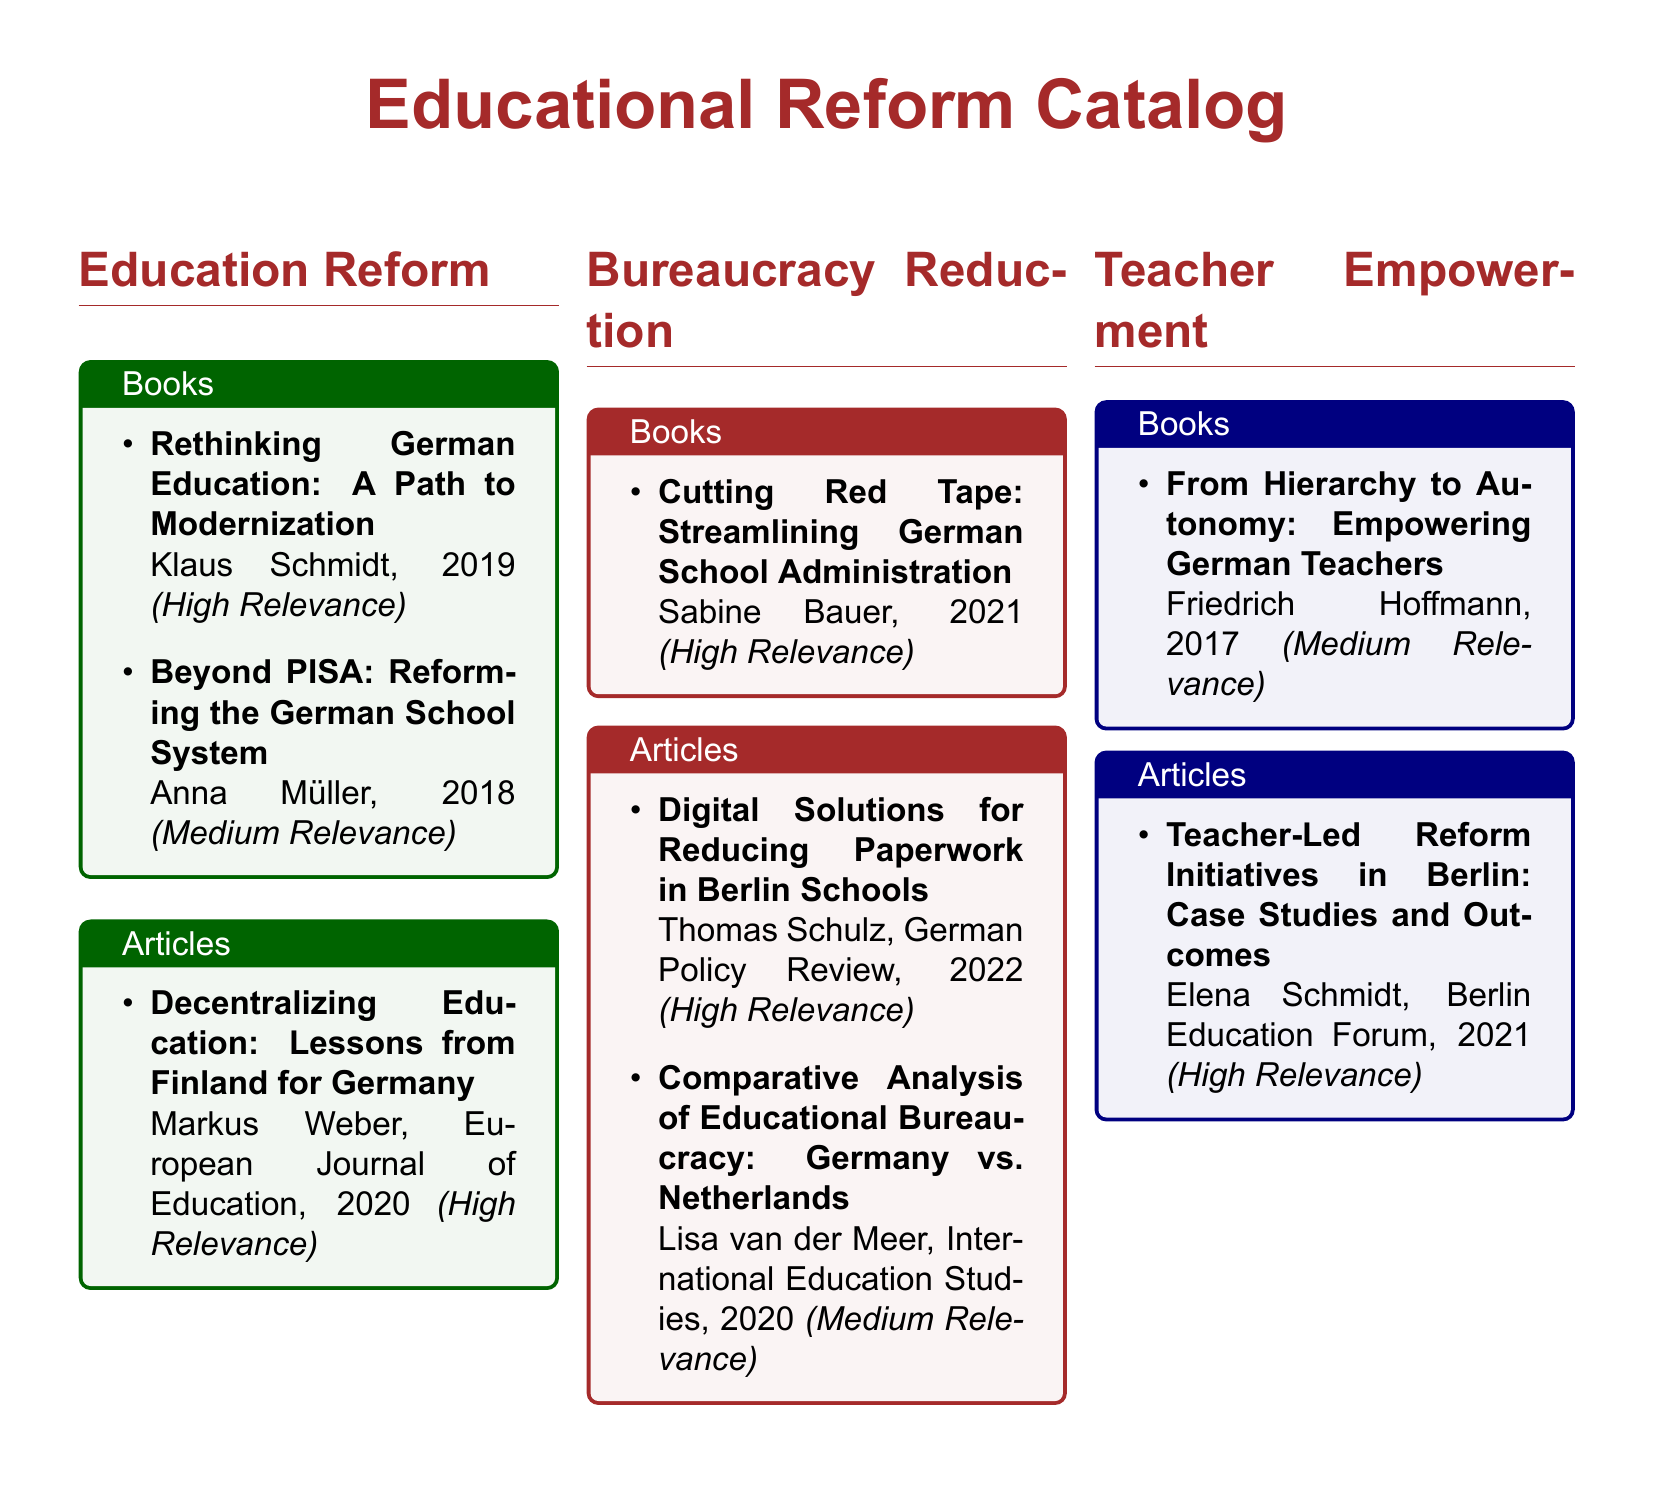What is the title of the book by Klaus Schmidt? The document lists the book titles and authors, providing that Klaus Schmidt's book is titled "Rethinking German Education: A Path to Modernization."
Answer: Rethinking German Education: A Path to Modernization Who authored the article about decentralizing education? The document specifies that the article titled "Decentralizing Education: Lessons from Finland for Germany" is authored by Markus Weber.
Answer: Markus Weber What year was "Cutting Red Tape: Streamlining German School Administration" published? The document provides publication information for books, indicating that "Cutting Red Tape: Streamlining German School Administration" was published in 2021.
Answer: 2021 Which publication discusses digital solutions for reducing paperwork? The document names articles, and "Digital Solutions for Reducing Paperwork in Berlin Schools" is listed as one such article.
Answer: Digital Solutions for Reducing Paperwork in Berlin Schools How many articles are listed under the Teacher Empowerment section? The document states that there is one article listed under Teacher Empowerment, which is "Teacher-Led Reform Initiatives in Berlin: Case Studies and Outcomes."
Answer: 1 What is the relevance level of the article by Lisa van der Meer? The document specifies the relevance level of articles, noting that Lisa van der Meer's article is of medium relevance.
Answer: Medium Relevance Which book focuses on empowering German teachers? The document indicates that "From Hierarchy to Autonomy: Empowering German Teachers" is the book that focuses on this topic.
Answer: From Hierarchy to Autonomy: Empowering German Teachers What is the main subject of the catalog? The document categorizes its content primarily around education reform and bureaucracy reduction in the German school system.
Answer: Education Reform and Bureaucracy Reduction 